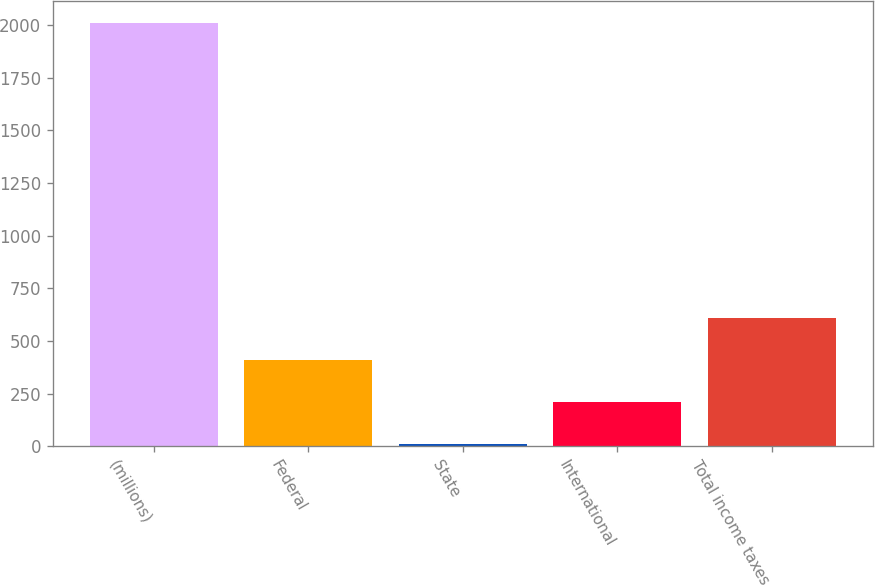Convert chart to OTSL. <chart><loc_0><loc_0><loc_500><loc_500><bar_chart><fcel>(millions)<fcel>Federal<fcel>State<fcel>International<fcel>Total income taxes<nl><fcel>2013<fcel>410.84<fcel>10.3<fcel>210.57<fcel>611.11<nl></chart> 